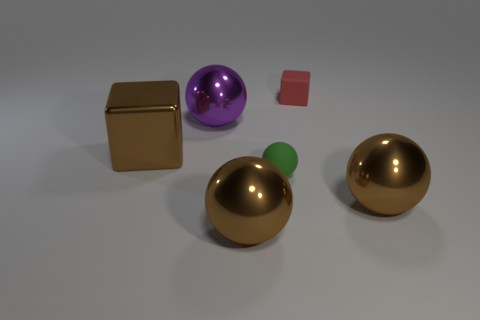Is there a big sphere of the same color as the big block? yes 